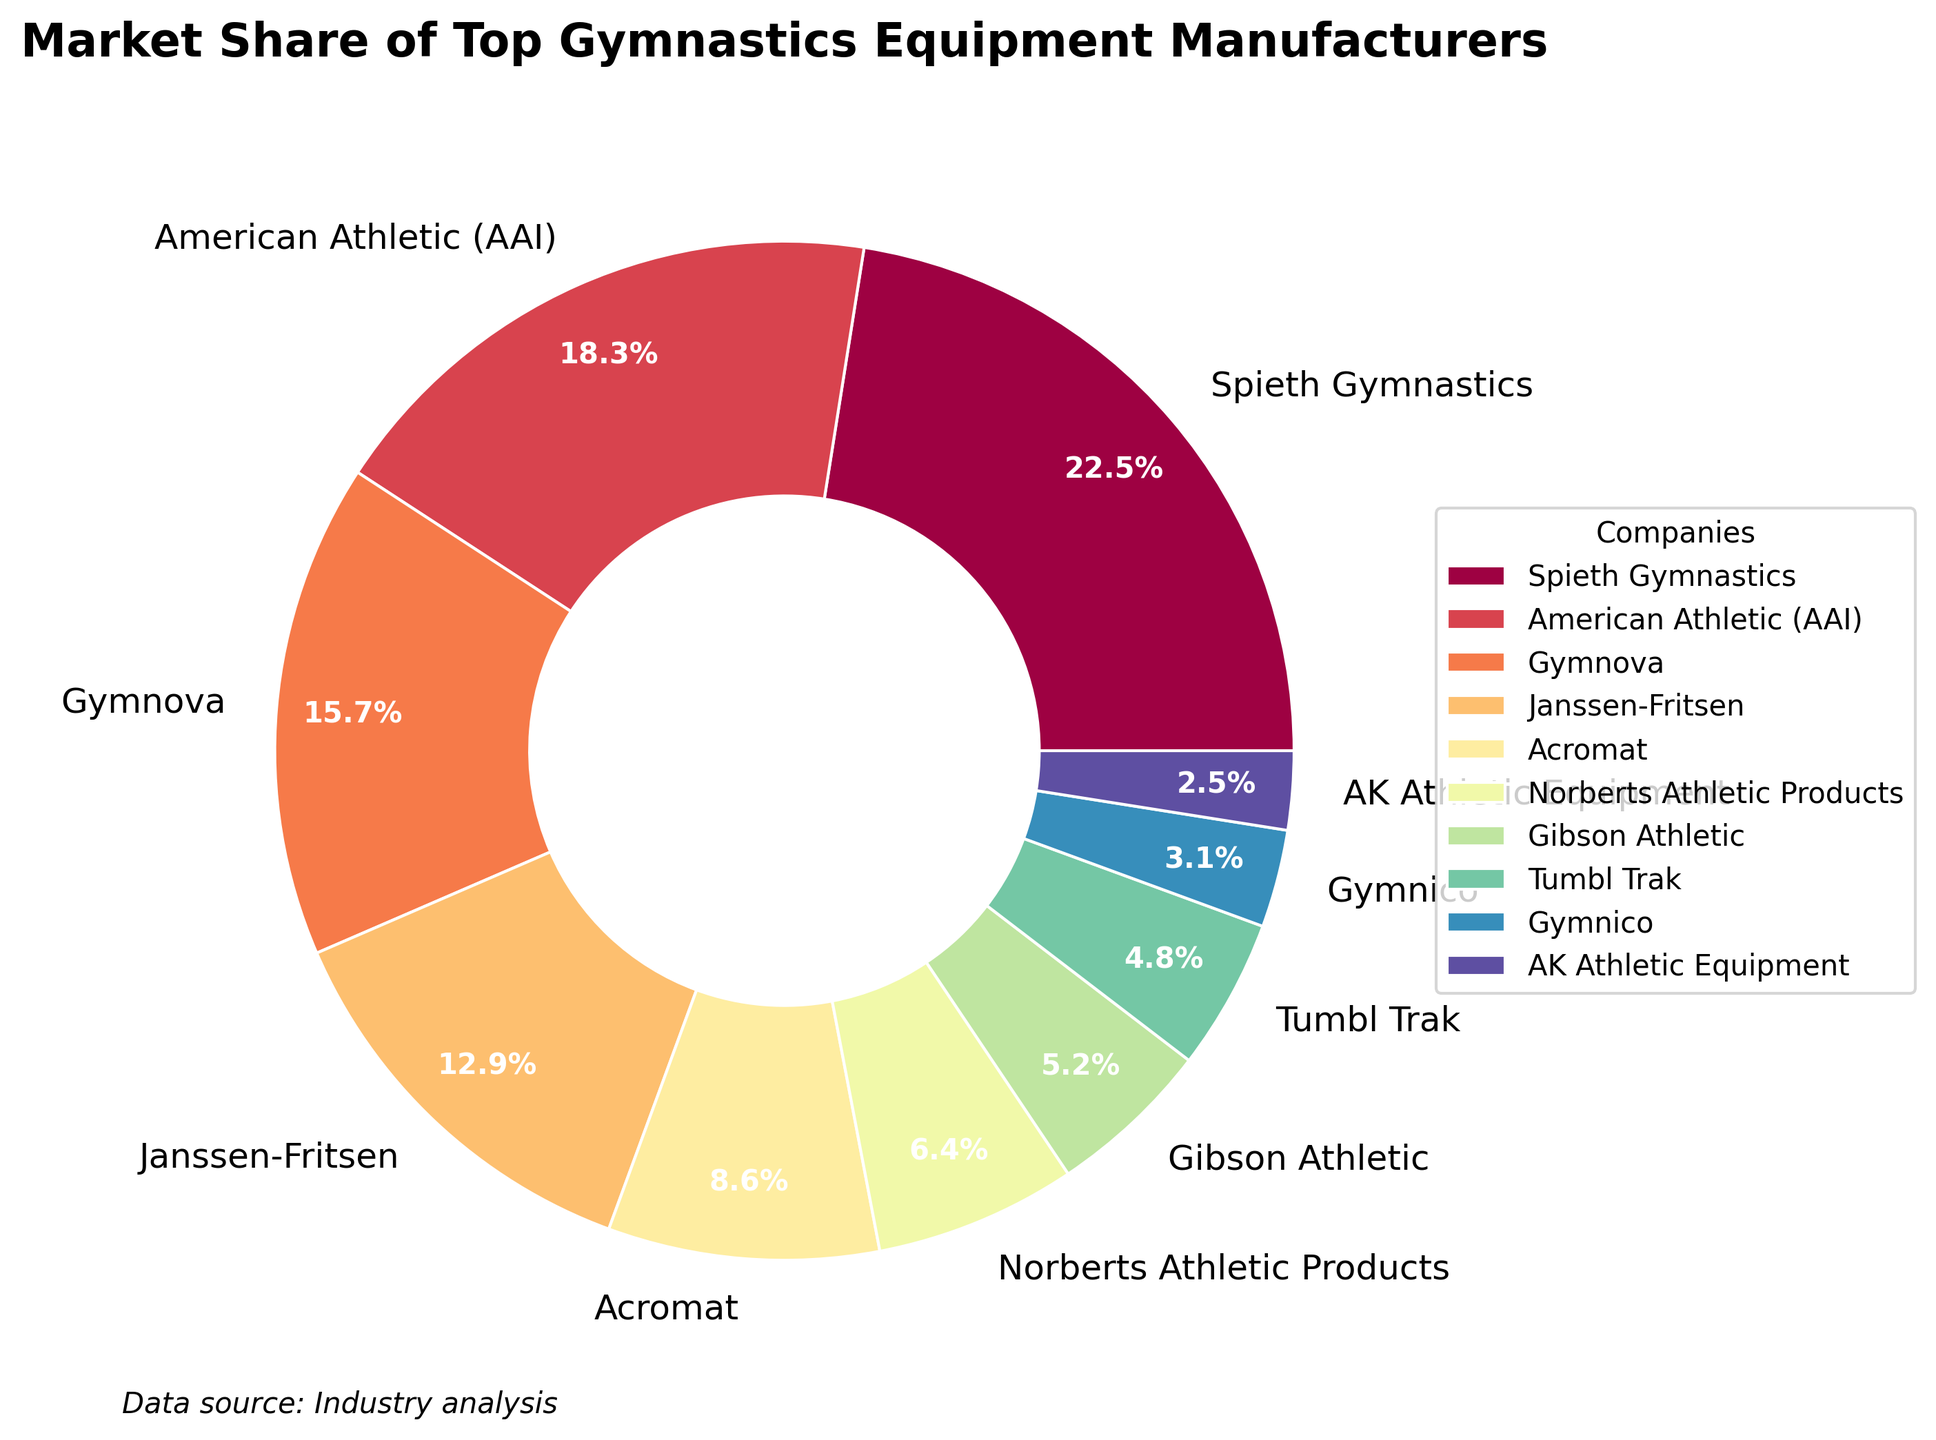What company has the largest market share? Refer to the pie chart, the company occupying the largest segment has a market share of 22.5%. This segment is labeled as Spieth Gymnastics.
Answer: Spieth Gymnastics Which two companies have a combined market share of over 30%? To find the combined market share, add the shares of two companies and check if the result exceeds 30%. Combining Spieth Gymnastics (22.5%) and American Athletic (AAI) (18.3%) gives 40.8%, which is over 30%.
Answer: Spieth Gymnastics, American Athletic (AAI) How much larger is Gymnova's market share compared to Acromat's? Subtract Acromat's market share (8.6%) from Gymnova's market share (15.7%). The result is 7.1%.
Answer: 7.1% Which company has the smallest market share? The pie chart shows the smallest segment at 2.5%, which is labeled as AK Athletic Equipment.
Answer: AK Athletic Equipment What is the combined market share of the bottom three companies? Summing the market shares of Norberts Athletic Products (6.4%), Gibson Athletic (5.2%), and AK Athletic Equipment (2.5%) yields 14.1%.
Answer: 14.1% Rank the top three companies based on their market share. By observing the pie chart, the top three companies in descending order of market share are Spieth Gymnastics (22.5%), American Athletic (AAI) (18.3%), and Gymnova (15.7%).
Answer: Spieth Gymnastics, American Athletic (AAI), Gymnova Which two companies have market shares closest to each other? Comparing the market shares, the closest values are for Tumbl Trak (4.8%) and Gymnico (3.1%), with a difference of 1.7%.
Answer: Tumbl Trak, Gymnico Is Gymnova's market share greater than the combined market share of the bottom four companies? Calculate Gymnova's share (15.7%) and add the shares of the bottom four companies: Norberts Athletic Products (6.4%), Gibson Athletic (5.2%), Tumbl Trak (4.8%), and AK Athletic Equipment (2.5%) which total 18.9%. 15.7% is less than 18.9%.
Answer: No How many companies have a market share greater than 10%? By reviewing the pie chart, the companies with greater than 10% are Spieth Gymnastics (22.5%), American Athletic (AAI) (18.3%), Gymnova (15.7%), and Janssen-Fritsen (12.9%), making a total of four companies.
Answer: 4 What is the combined market share of the companies with less than 5%? Sum the shares of Gymnico (3.1%) and AK Athletic Equipment (2.5%), resulting in 5.6%.
Answer: 5.6% 